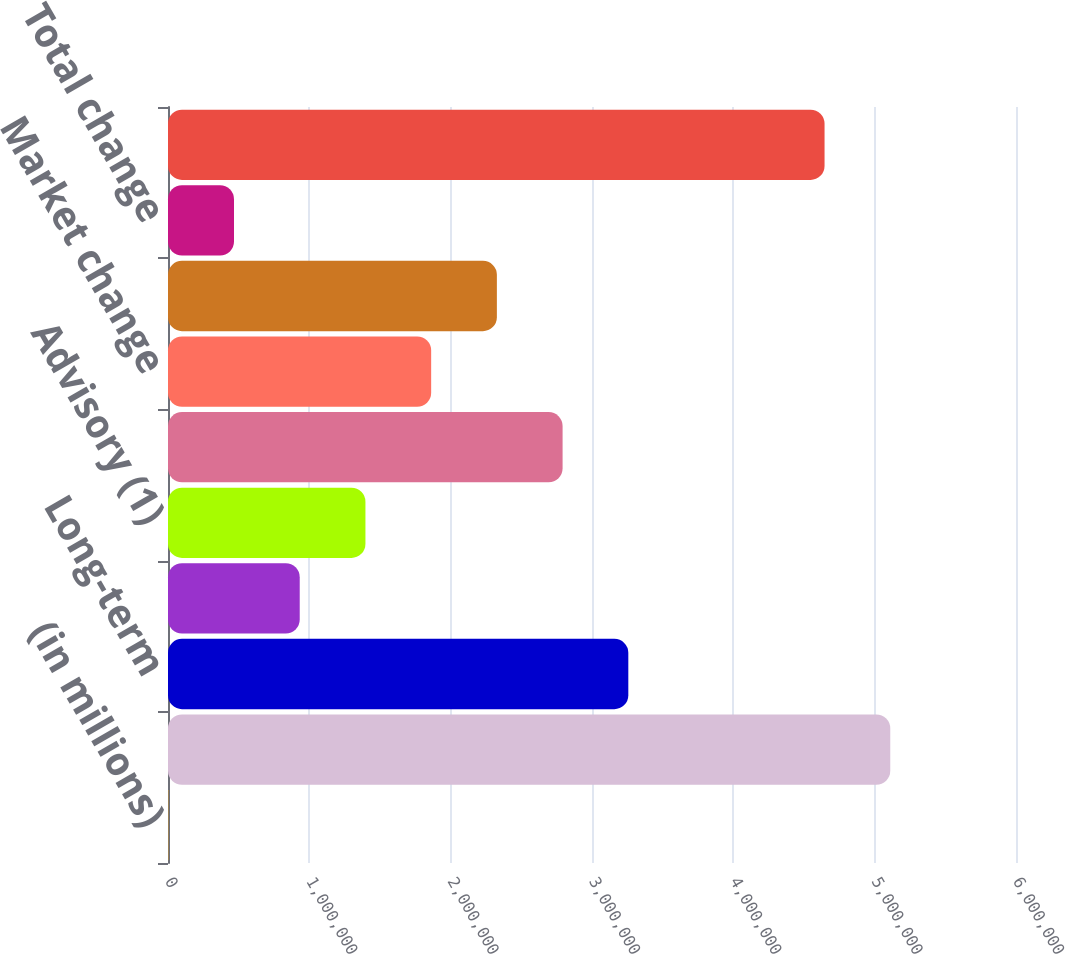Convert chart to OTSL. <chart><loc_0><loc_0><loc_500><loc_500><bar_chart><fcel>(in millions)<fcel>Beginning assets under<fcel>Long-term<fcel>Cash management<fcel>Advisory (1)<fcel>Total net inflows (outflows)<fcel>Market change<fcel>FX impact (3)<fcel>Total change<fcel>Ending assets under management<nl><fcel>2015<fcel>5.1104e+06<fcel>3.25693e+06<fcel>931991<fcel>1.39698e+06<fcel>2.79194e+06<fcel>1.86197e+06<fcel>2.32696e+06<fcel>467003<fcel>4.64541e+06<nl></chart> 